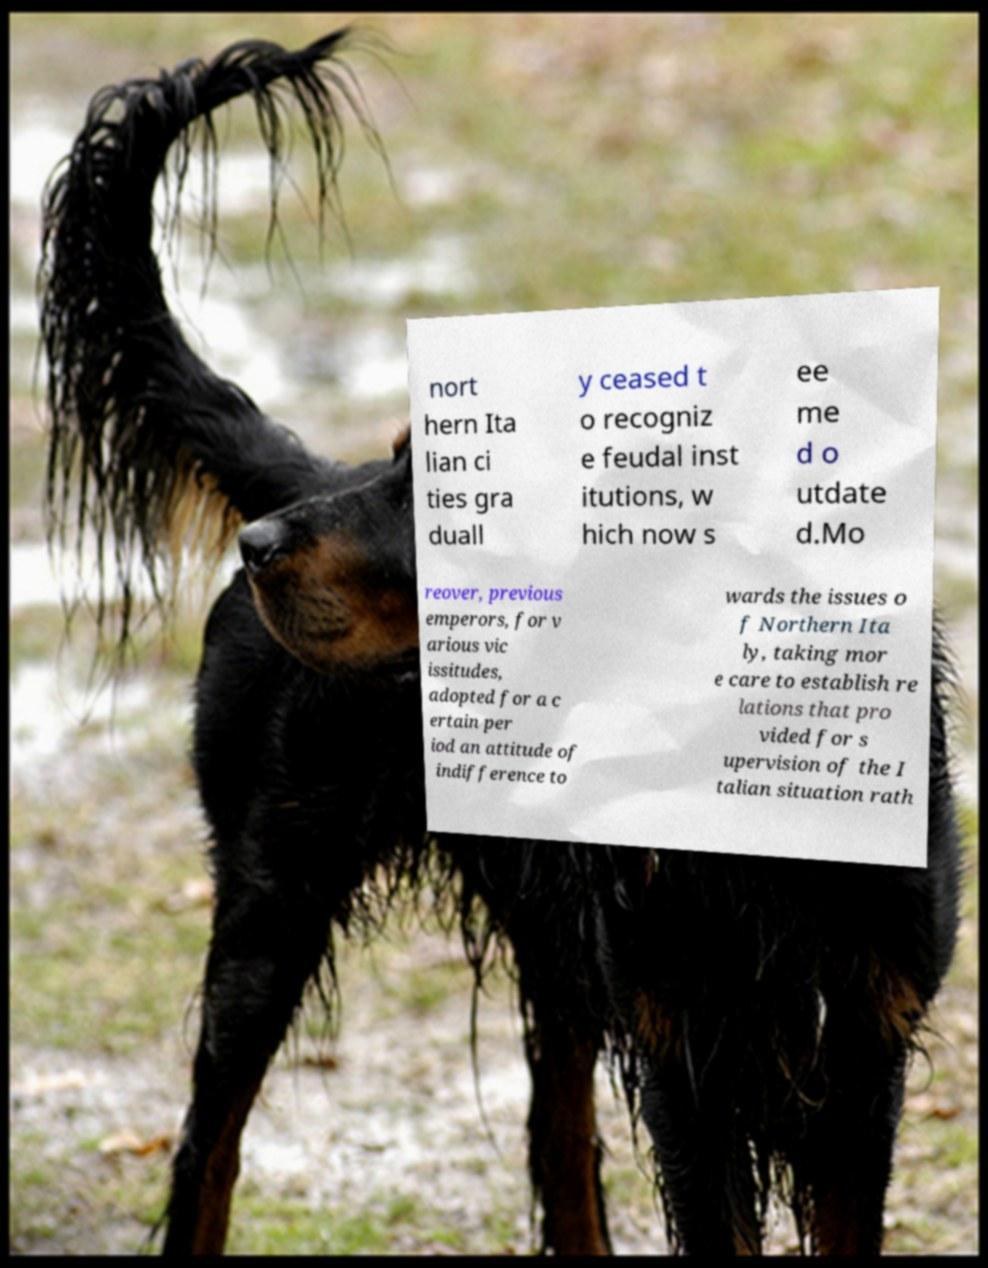Could you assist in decoding the text presented in this image and type it out clearly? nort hern Ita lian ci ties gra duall y ceased t o recogniz e feudal inst itutions, w hich now s ee me d o utdate d.Mo reover, previous emperors, for v arious vic issitudes, adopted for a c ertain per iod an attitude of indifference to wards the issues o f Northern Ita ly, taking mor e care to establish re lations that pro vided for s upervision of the I talian situation rath 